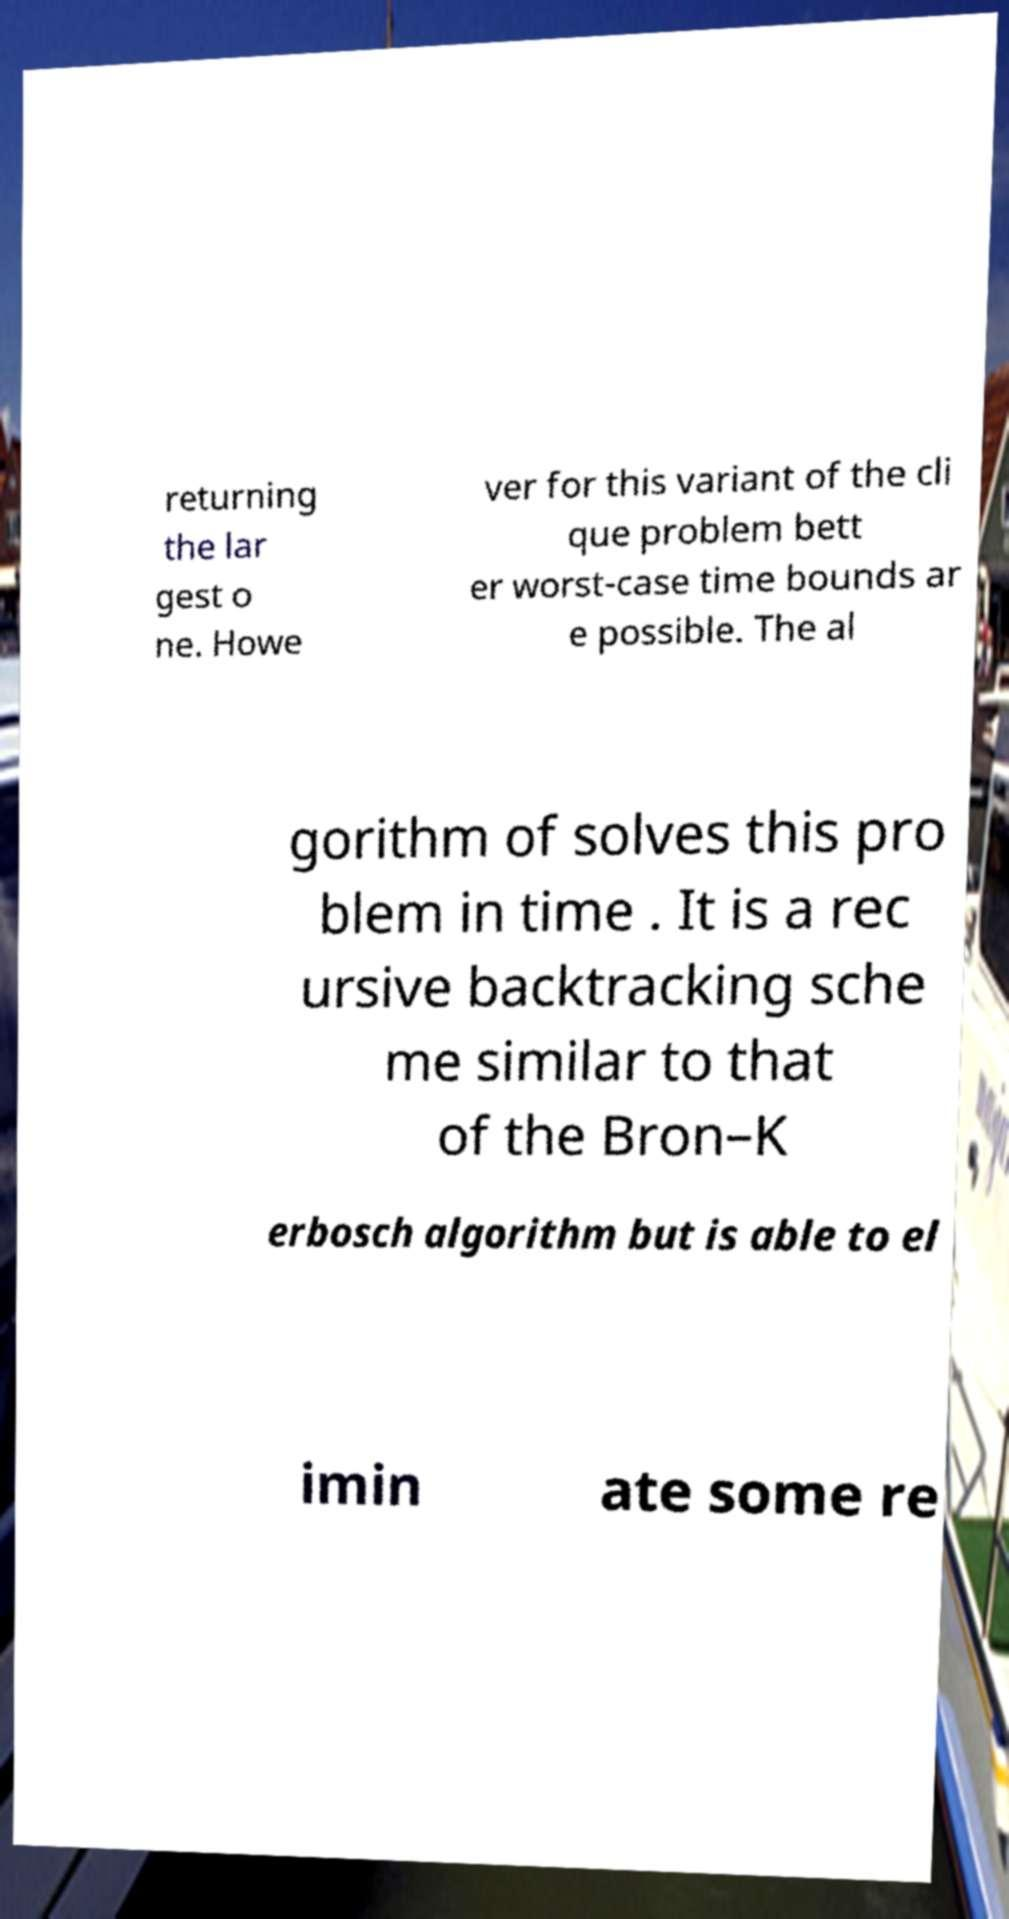Can you read and provide the text displayed in the image?This photo seems to have some interesting text. Can you extract and type it out for me? returning the lar gest o ne. Howe ver for this variant of the cli que problem bett er worst-case time bounds ar e possible. The al gorithm of solves this pro blem in time . It is a rec ursive backtracking sche me similar to that of the Bron–K erbosch algorithm but is able to el imin ate some re 